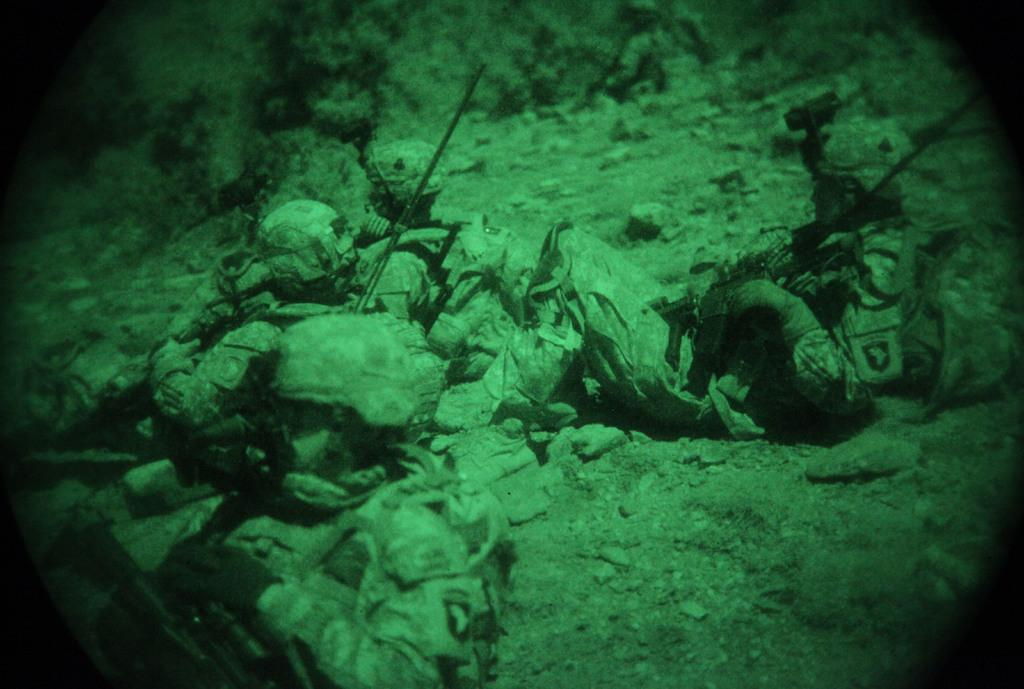How many people are in the image? There is a group of people in the image. What are the people doing in the image? The people are lying on the ground. What type of industry can be seen in the background of the image? There is no industry visible in the image; it only shows a group of people lying on the ground. What kind of flame is present in the image? There is no flame present in the image. 